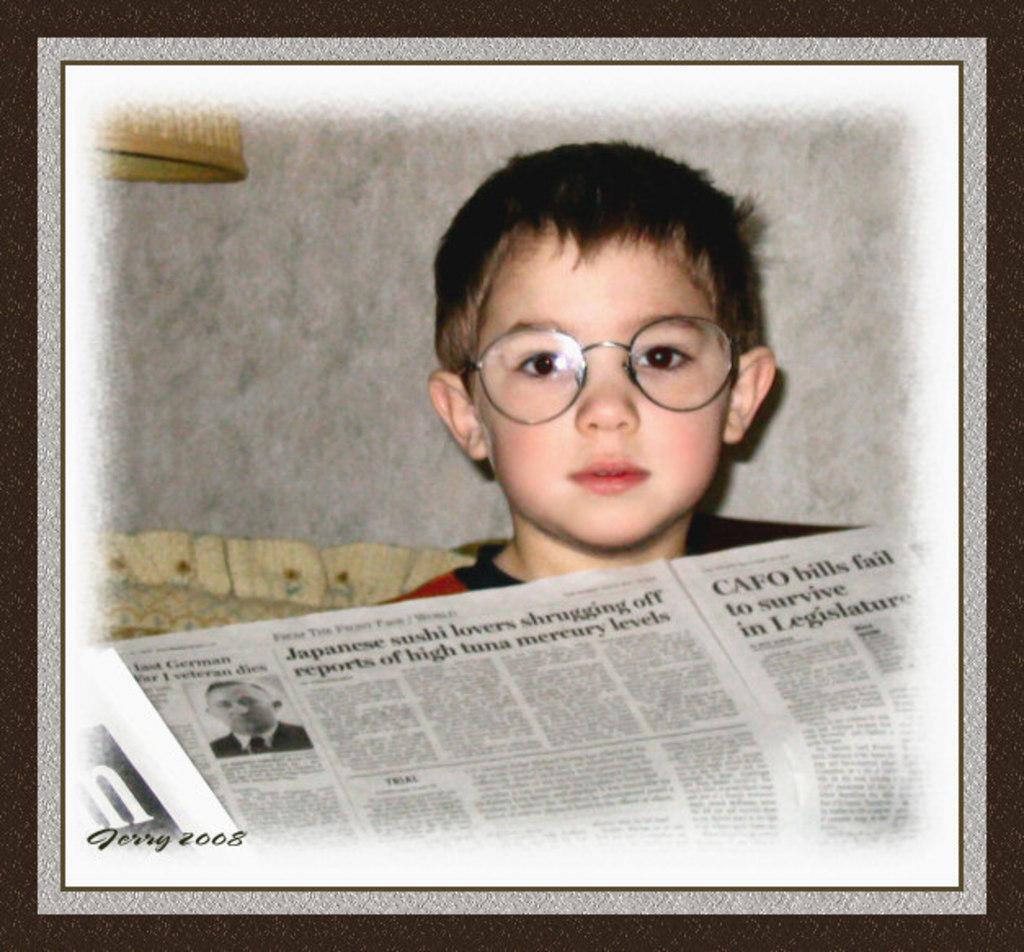Describe this image in one or two sentences. In this image there is a boy, newspaper and objects. At the bottom left side of the image there is a watermark.   